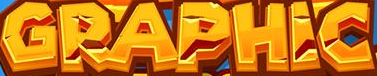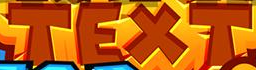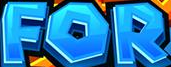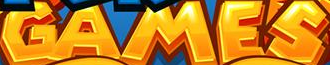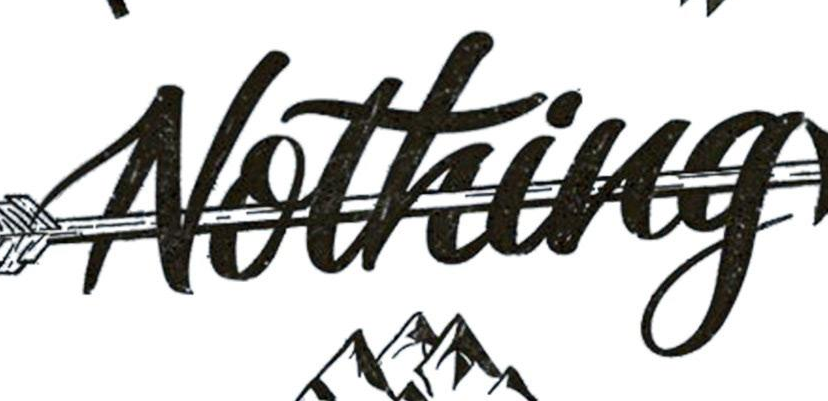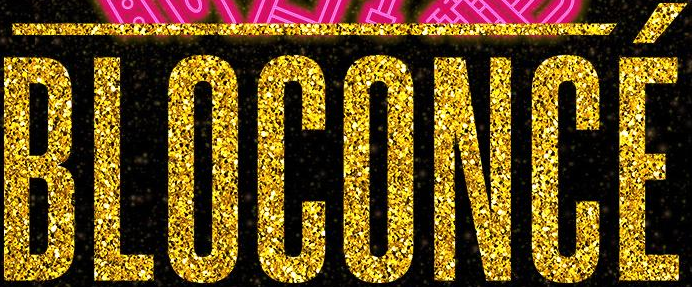What text is displayed in these images sequentially, separated by a semicolon? GRAPHIC; TEXT; FOR; GAMES; Nothing; BLOCONCÉ 